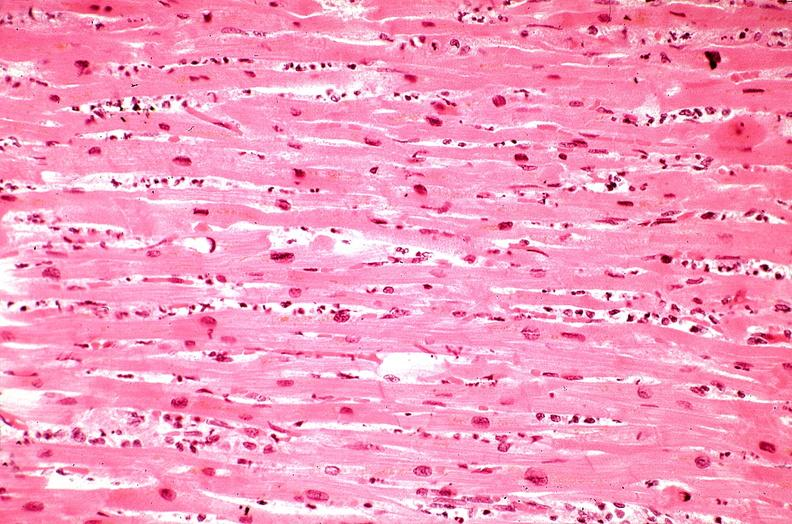where is this from?
Answer the question using a single word or phrase. Heart 